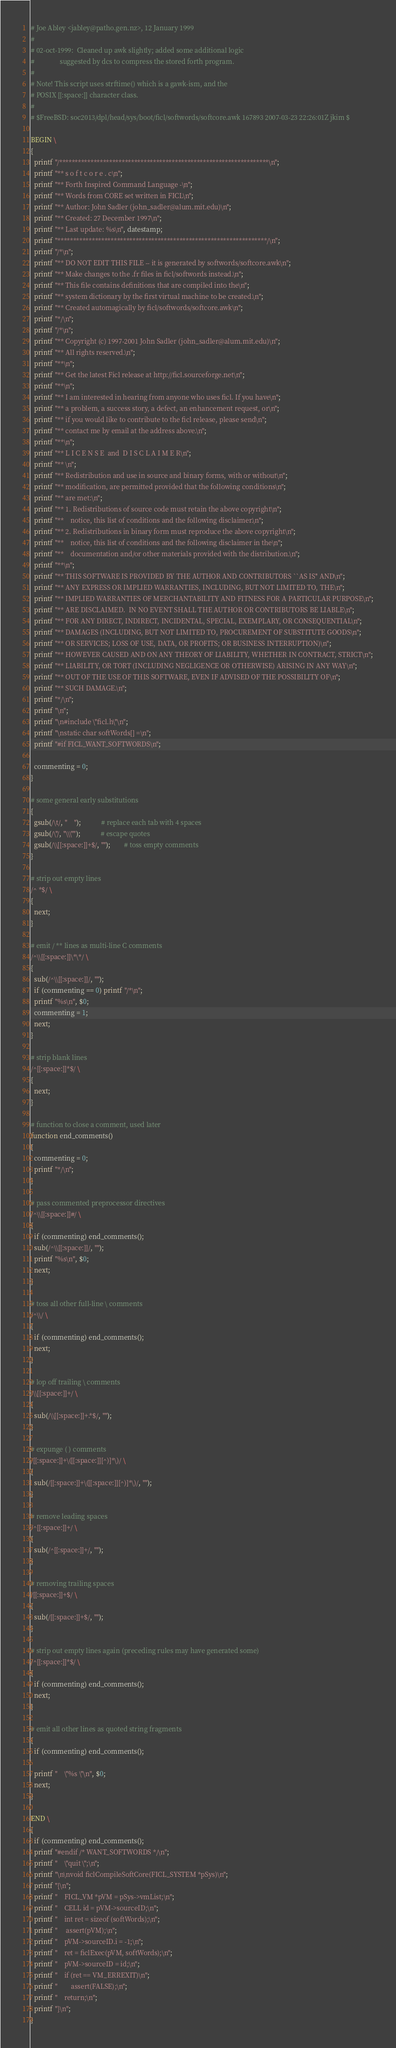Convert code to text. <code><loc_0><loc_0><loc_500><loc_500><_Awk_># Joe Abley <jabley@patho.gen.nz>, 12 January 1999
#
# 02-oct-1999:  Cleaned up awk slightly; added some additional logic
#               suggested by dcs to compress the stored forth program.
#
# Note! This script uses strftime() which is a gawk-ism, and the
# POSIX [[:space:]] character class.
#
# $FreeBSD: soc2013/dpl/head/sys/boot/ficl/softwords/softcore.awk 167893 2007-03-23 22:26:01Z jkim $

BEGIN \
{
  printf "/*******************************************************************\n";
  printf "** s o f t c o r e . c\n";
  printf "** Forth Inspired Command Language -\n";
  printf "** Words from CORE set written in FICL\n";
  printf "** Author: John Sadler (john_sadler@alum.mit.edu)\n";
  printf "** Created: 27 December 1997\n";
  printf "** Last update: %s\n", datestamp;
  printf "*******************************************************************/\n";
  printf "/*\n";
  printf "** DO NOT EDIT THIS FILE -- it is generated by softwords/softcore.awk\n";
  printf "** Make changes to the .fr files in ficl/softwords instead.\n";
  printf "** This file contains definitions that are compiled into the\n";
  printf "** system dictionary by the first virtual machine to be created.\n";
  printf "** Created automagically by ficl/softwords/softcore.awk\n";
  printf "*/\n";
  printf "/*\n";
  printf "** Copyright (c) 1997-2001 John Sadler (john_sadler@alum.mit.edu)\n";
  printf "** All rights reserved.\n";
  printf "**\n";
  printf "** Get the latest Ficl release at http://ficl.sourceforge.net\n";
  printf "**\n";
  printf "** I am interested in hearing from anyone who uses ficl. If you have\n";
  printf "** a problem, a success story, a defect, an enhancement request, or\n";
  printf "** if you would like to contribute to the ficl release, please send\n";
  printf "** contact me by email at the address above.\n";
  printf "**\n";
  printf "** L I C E N S E  and  D I S C L A I M E R\n";
  printf "** \n";
  printf "** Redistribution and use in source and binary forms, with or without\n";
  printf "** modification, are permitted provided that the following conditions\n";
  printf "** are met:\n";
  printf "** 1. Redistributions of source code must retain the above copyright\n";
  printf "**    notice, this list of conditions and the following disclaimer.\n";
  printf "** 2. Redistributions in binary form must reproduce the above copyright\n";
  printf "**    notice, this list of conditions and the following disclaimer in the\n";
  printf "**    documentation and/or other materials provided with the distribution.\n";
  printf "**\n";
  printf "** THIS SOFTWARE IS PROVIDED BY THE AUTHOR AND CONTRIBUTORS ``AS IS'' AND\n";
  printf "** ANY EXPRESS OR IMPLIED WARRANTIES, INCLUDING, BUT NOT LIMITED TO, THE\n";
  printf "** IMPLIED WARRANTIES OF MERCHANTABILITY AND FITNESS FOR A PARTICULAR PURPOSE\n";
  printf "** ARE DISCLAIMED.  IN NO EVENT SHALL THE AUTHOR OR CONTRIBUTORS BE LIABLE\n";
  printf "** FOR ANY DIRECT, INDIRECT, INCIDENTAL, SPECIAL, EXEMPLARY, OR CONSEQUENTIAL\n";
  printf "** DAMAGES (INCLUDING, BUT NOT LIMITED TO, PROCUREMENT OF SUBSTITUTE GOODS\n";
  printf "** OR SERVICES; LOSS OF USE, DATA, OR PROFITS; OR BUSINESS INTERRUPTION)\n";
  printf "** HOWEVER CAUSED AND ON ANY THEORY OF LIABILITY, WHETHER IN CONTRACT, STRICT\n";
  printf "** LIABILITY, OR TORT (INCLUDING NEGLIGENCE OR OTHERWISE) ARISING IN ANY WAY\n";
  printf "** OUT OF THE USE OF THIS SOFTWARE, EVEN IF ADVISED OF THE POSSIBILITY OF\n";
  printf "** SUCH DAMAGE.\n";
  printf "*/\n";
  printf "\n";
  printf "\n#include \"ficl.h\"\n";
  printf "\nstatic char softWords[] =\n";
  printf "#if FICL_WANT_SOFTWORDS\n";

  commenting = 0;
}

# some general early substitutions
{
  gsub(/\t/, "    ");			# replace each tab with 4 spaces
  gsub(/\"/, "\\\"");			# escape quotes
  gsub(/\\[[:space:]]+$/, "");		# toss empty comments
}

# strip out empty lines
/^ *$/ \
{
  next;
}

# emit / ** lines as multi-line C comments
/^\\[[:space:]]\*\*/ \
{
  sub(/^\\[[:space:]]/, "");
  if (commenting == 0) printf "/*\n";
  printf "%s\n", $0;
  commenting = 1;
  next;
}

# strip blank lines
/^[[:space:]]*$/ \
{
  next;
}

# function to close a comment, used later
function end_comments()
{
  commenting = 0;
  printf "*/\n";
}

# pass commented preprocessor directives
/^\\[[:space:]]#/ \
{
  if (commenting) end_comments();
  sub(/^\\[[:space:]]/, "");
  printf "%s\n", $0;
  next;
}

# toss all other full-line \ comments
/^\\/ \
{
  if (commenting) end_comments();
  next;
}

# lop off trailing \ comments
/\\[[:space:]]+/ \
{
  sub(/\\[[:space:]]+.*$/, "");
}

# expunge ( ) comments
/[[:space:]]+\([[:space:]][^)]*\)/ \
{
  sub(/[[:space:]]+\([[:space:]][^)]*\)/, "");
}

# remove leading spaces
/^[[:space:]]+/ \
{
  sub(/^[[:space:]]+/, "");
}

# removing trailing spaces
/[[:space:]]+$/ \
{
  sub(/[[:space:]]+$/, "");
}

# strip out empty lines again (preceding rules may have generated some)
/^[[:space:]]*$/ \
{
  if (commenting) end_comments();
  next;
}

# emit all other lines as quoted string fragments
{
  if (commenting) end_comments();

  printf "    \"%s \"\n", $0;
  next;
}

END \
{
  if (commenting) end_comments();
  printf "#endif /* WANT_SOFTWORDS */\n";
  printf "    \"quit \";\n";
  printf "\n\nvoid ficlCompileSoftCore(FICL_SYSTEM *pSys)\n";
  printf "{\n";
  printf "    FICL_VM *pVM = pSys->vmList;\n";
  printf "    CELL id = pVM->sourceID;\n";
  printf "    int ret = sizeof (softWords);\n";
  printf "	  assert(pVM);\n";
  printf "    pVM->sourceID.i = -1;\n";
  printf "    ret = ficlExec(pVM, softWords);\n";
  printf "    pVM->sourceID = id;\n";
  printf "    if (ret == VM_ERREXIT)\n";
  printf "        assert(FALSE);\n";
  printf "    return;\n";
  printf "}\n";
}
</code> 